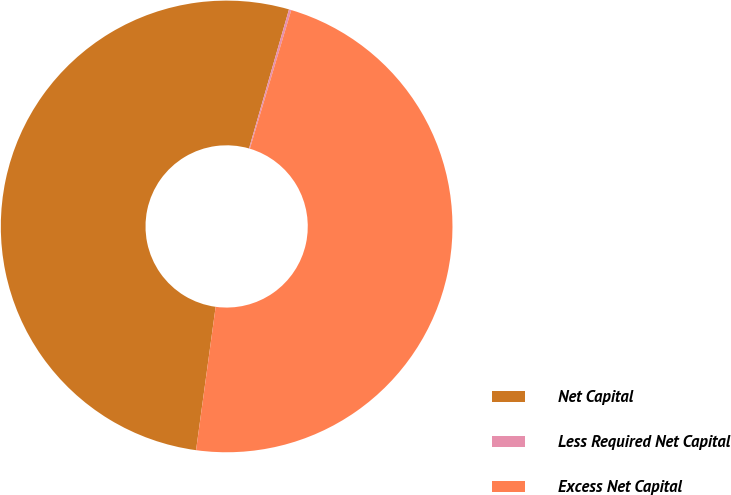Convert chart to OTSL. <chart><loc_0><loc_0><loc_500><loc_500><pie_chart><fcel>Net Capital<fcel>Less Required Net Capital<fcel>Excess Net Capital<nl><fcel>52.29%<fcel>0.17%<fcel>47.54%<nl></chart> 